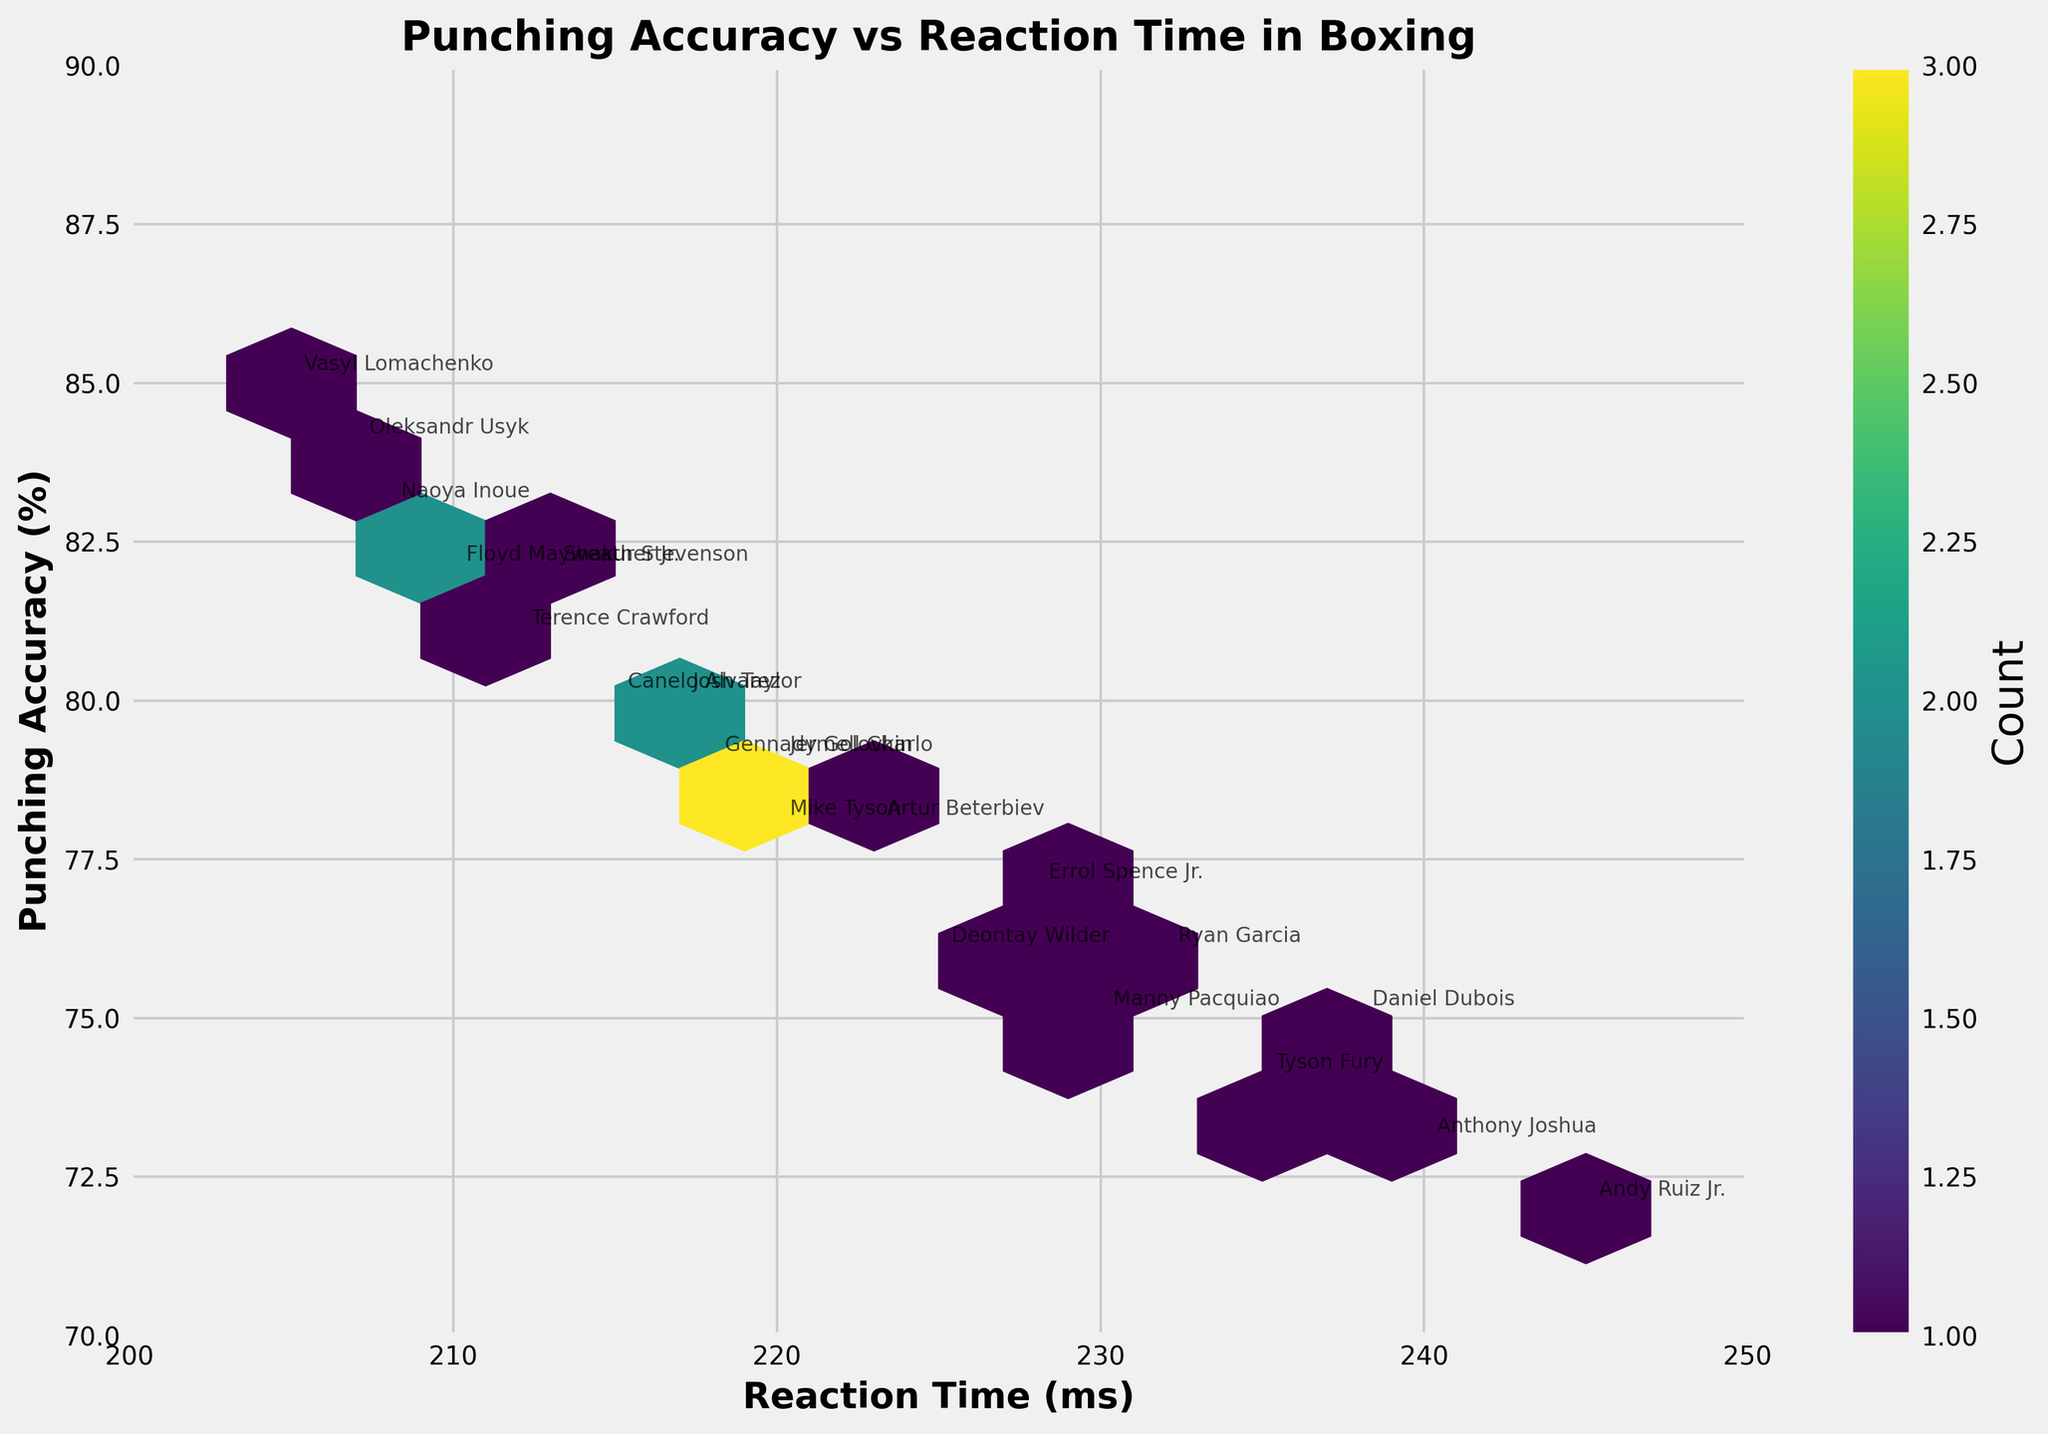What is the title of the plot? The title of the plot is typically at the top of the figure. In this case, based on the information provided, the title is clearly indicated at the top of the rendered figure as "Punching Accuracy vs Reaction Time in Boxing".
Answer: Punching Accuracy vs Reaction Time in Boxing What is the x-axis label? The x-axis label is found at the bottom of the horizontal axis. According to the provided data and code, it is labeled as "Reaction Time (ms)".
Answer: Reaction Time (ms) What is the y-axis label? The y-axis label is found at the side of the vertical axis. Based on the provided data and code, it is labeled as "Punching Accuracy (%)".
Answer: Punching Accuracy (%) How many data points are there in the plot? Each boxer's data point represents a unique combination of punching accuracy and reaction time. Looking at the data provided, there are a total of 20 boxers, so there are 20 data points.
Answer: 20 Which boxer has the best punching accuracy? From the data provided, punching accuracy and boxer names are annotated. The highest punching accuracy percentage is 85%. By identifying the name associated with this value, we see it is Vasyl Lomachenko.
Answer: Vasyl Lomachenko Which boxer has the fastest reaction time? The fastest reaction time is the smallest value in the data set, which is 205 ms. According to the annotations, Vasyl Lomachenko has the fastest reaction time.
Answer: Vasyl Lomachenko Which boxer has the slowest reaction time? The slowest reaction time is the largest value in the data set, which is 245 ms. From the annotations, it is Andy Ruiz Jr.
Answer: Andy Ruiz Jr What is the general relationship between punching accuracy and reaction time? To understand the general relationship, look at the trend of the data points in the hexbin plot. Punching accuracy tends to slightly increase as reaction time decreases, indicating a negative correlation.
Answer: Negative correlation What is the color intensity indicating in the hexbin plot? The color intensity in a hexbin plot represents the density or count of data points within each hexagon. The color bar shows that darker or more intense colors indicate higher densities.
Answer: Density of data points Which boxer with a reaction time of 210 ms has the highest punching accuracy, and what is it? To find this, we look for the data point at 210 ms along the x-axis and check the annotated accuracy. According to the data, Floyd Mayweather Jr. has a reaction time of 210 ms with a punching accuracy of 82%.
Answer: Floyd Mayweather Jr.; 82% 